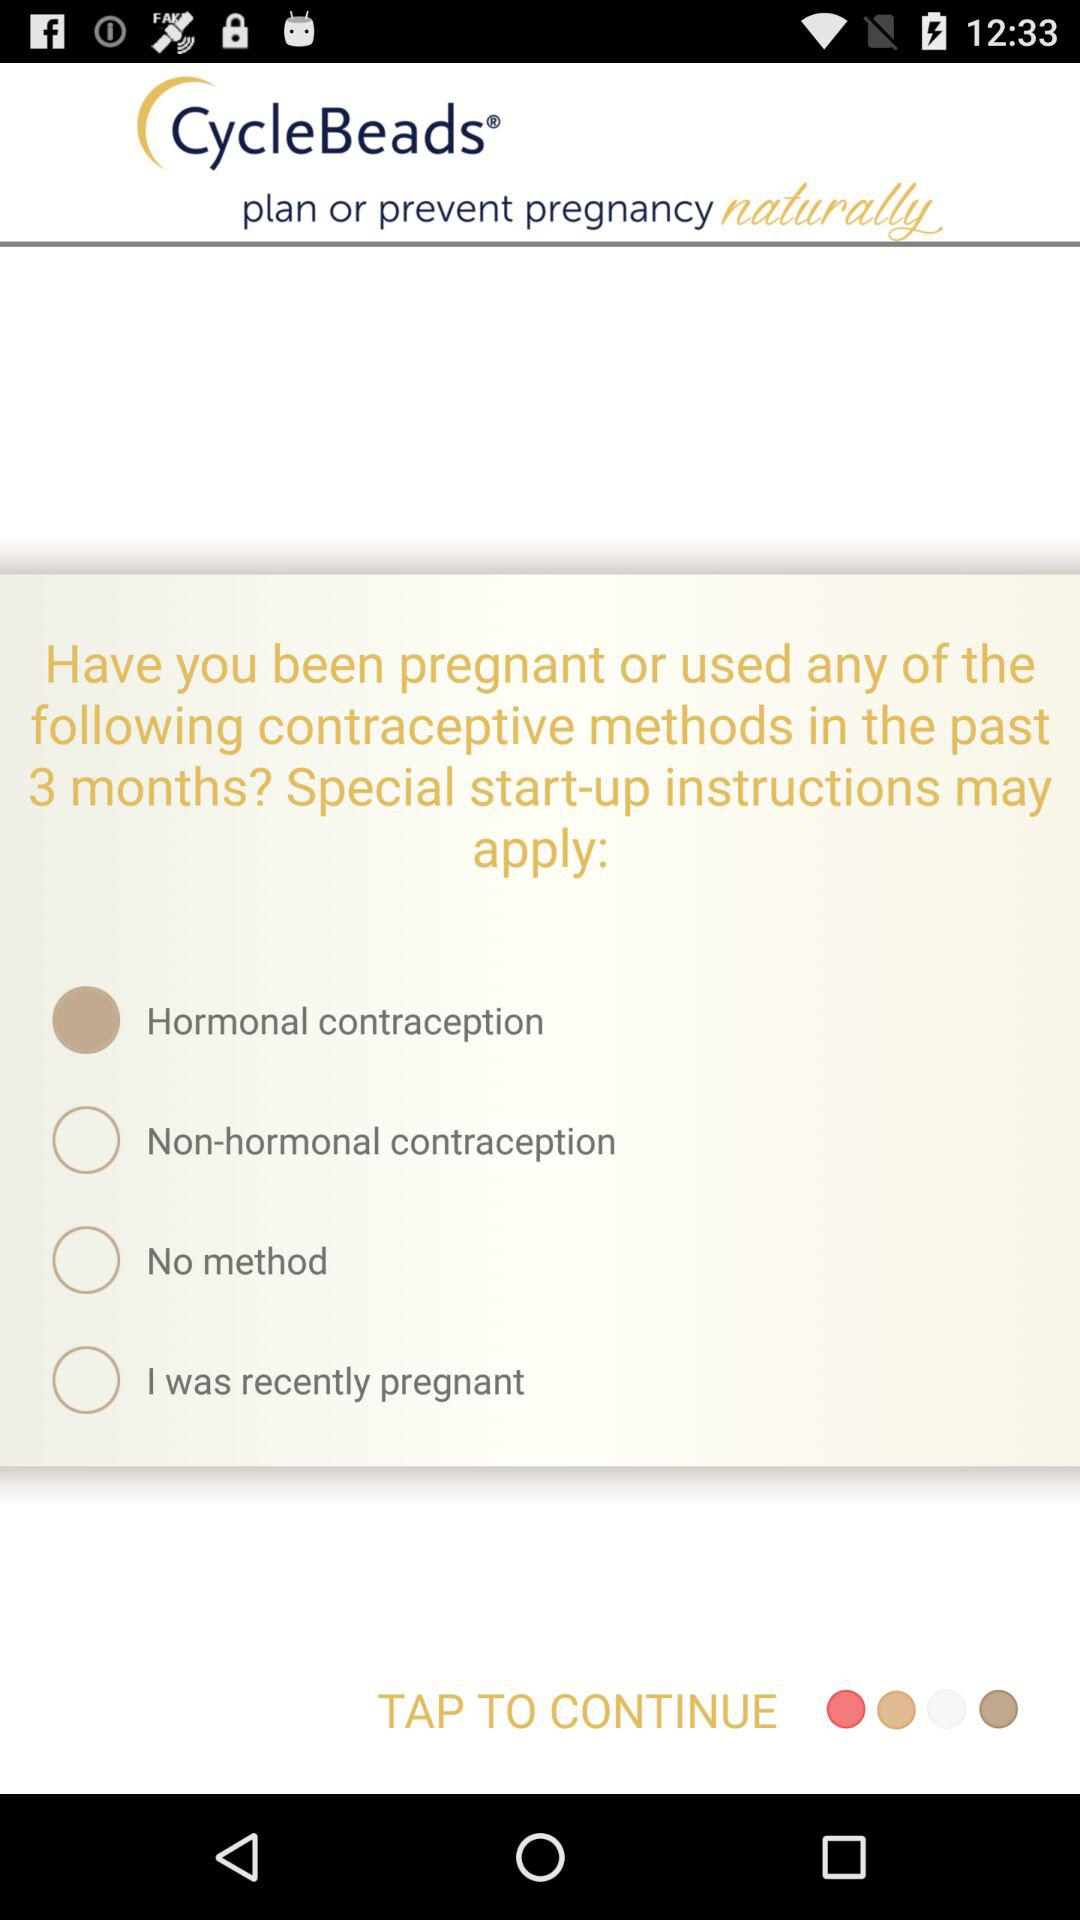What is the name of the application? The name of the application is "CycleBeads". 